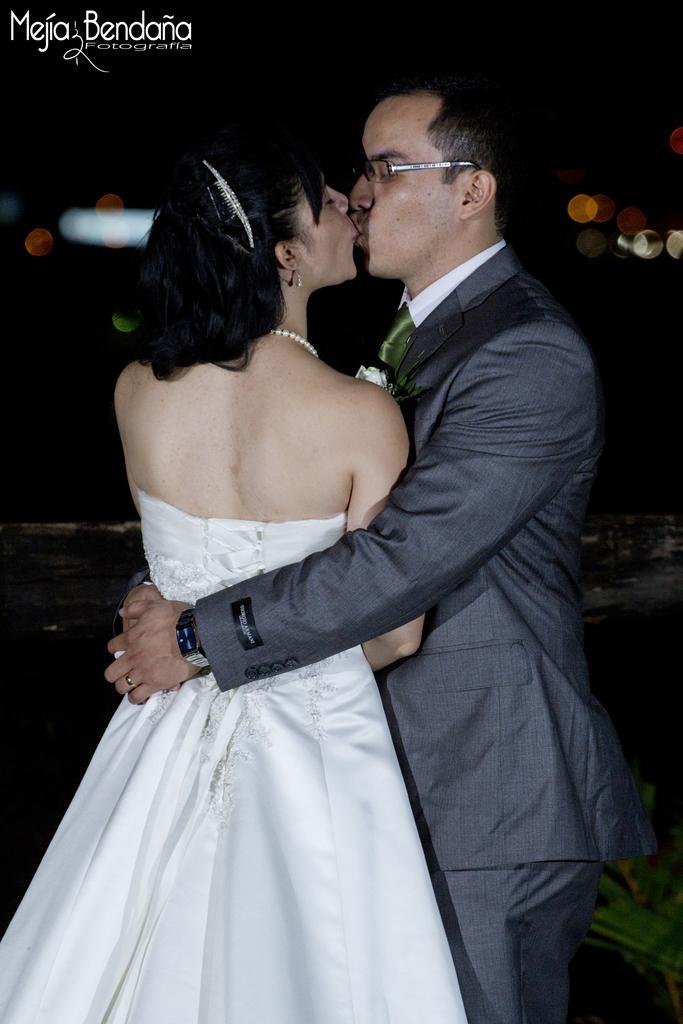Please provide a concise description of this image. Here I can see a man and a woman are standing and kissing. The man is wearing a suit and trouser. The woman is wearing a white color frock. The background is in black color. At the top left there is some text. 